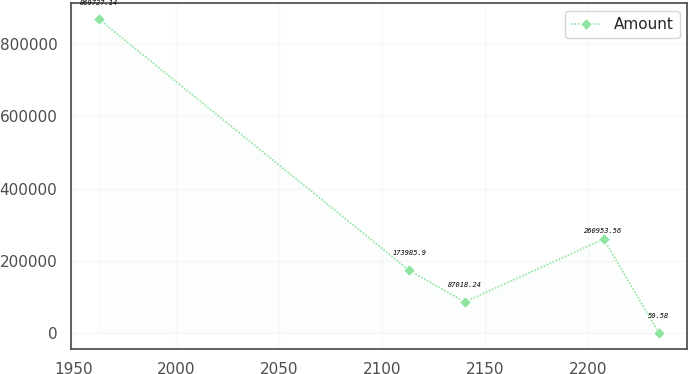<chart> <loc_0><loc_0><loc_500><loc_500><line_chart><ecel><fcel>Amount<nl><fcel>1962.32<fcel>869727<nl><fcel>2113.08<fcel>173986<nl><fcel>2139.98<fcel>87018.2<nl><fcel>2207.41<fcel>260954<nl><fcel>2234.31<fcel>50.58<nl></chart> 